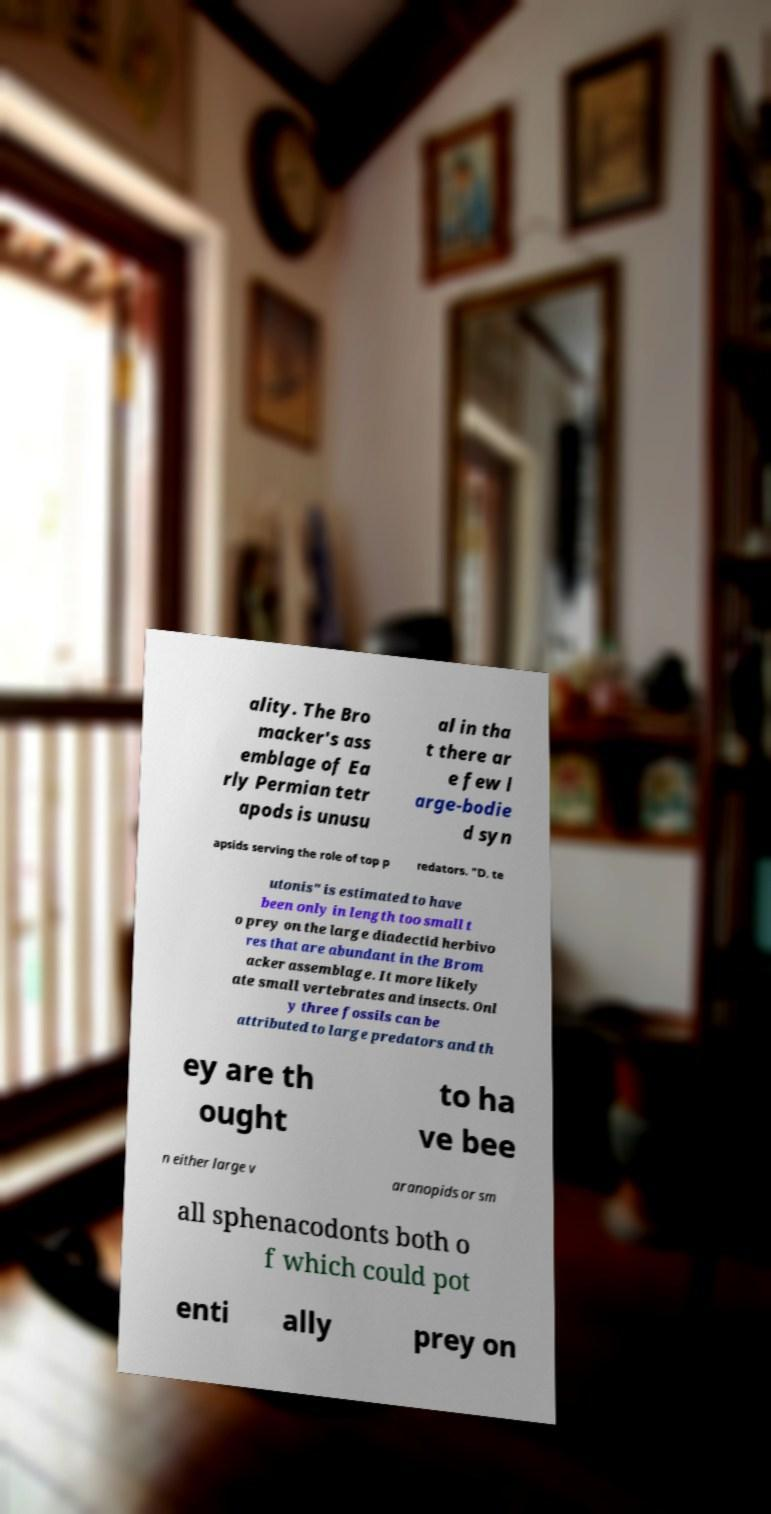Can you read and provide the text displayed in the image?This photo seems to have some interesting text. Can you extract and type it out for me? ality. The Bro macker's ass emblage of Ea rly Permian tetr apods is unusu al in tha t there ar e few l arge-bodie d syn apsids serving the role of top p redators. "D. te utonis" is estimated to have been only in length too small t o prey on the large diadectid herbivo res that are abundant in the Brom acker assemblage. It more likely ate small vertebrates and insects. Onl y three fossils can be attributed to large predators and th ey are th ought to ha ve bee n either large v aranopids or sm all sphenacodonts both o f which could pot enti ally prey on 